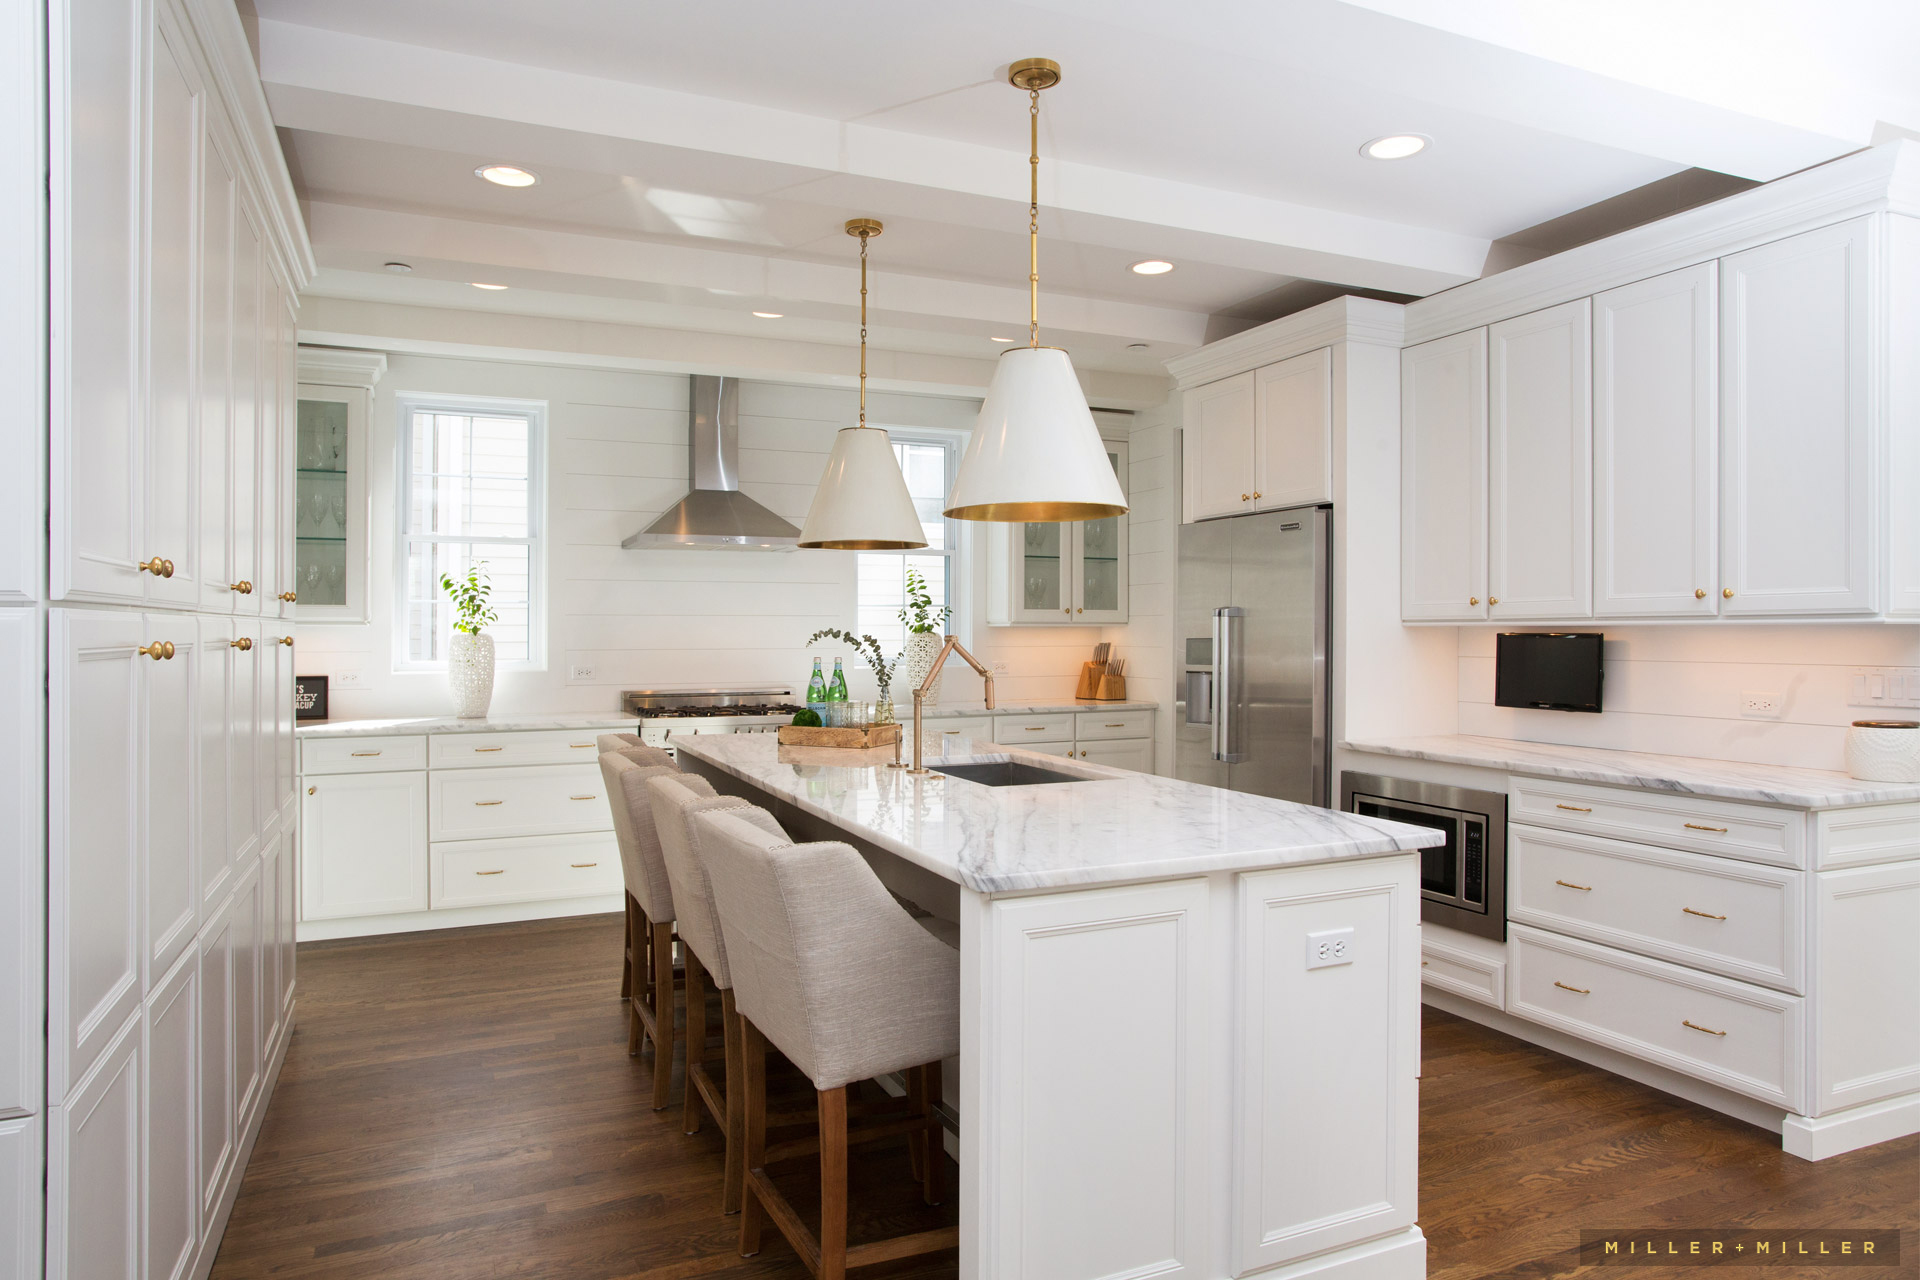If this kitchen could tell a story, what would it be? If this kitchen could tell a story, it would speak of countless shared moments and culinary adventures. It would recall the laughter of friends gathered around the island, the joyful chaos of holiday feasts, and the quiet mornings when the smell of freshly brewed coffee filled the air. This kitchen has witnessed the growth of a family, from the first steps of a child on its warm wooden floor to the hushed, late-night conversations. It would narrate the expertise honed over time, with each dish prepared on its resilient marble countertop and every appliance working seamlessly to create gastronomic delights. This kitchen embodies not just functionality, but also the heart of a home where every element works together to create a warm, inviting, and nurturing environment. How might this kitchen look in a futuristic, sci-fi inspired design? In a futuristic, sci-fi inspired design, this kitchen would undergo a stunning transformation. The countertops could be made of sleek, self-cleaning surfaces that change color according to the user’s mood or needs. Smart walls would display recipes, cooking videos, and personal messages, integrating seamlessly with AI assistants to perform tasks on command. Appliances might be voice-activated and could include multi-functional gadgets that cook, clean, and even dispense nutrition-enhanced meals. The cabinetry could have touch-sensitive panels that open with a light tap, while underfloor heating could adjust according to foot traffic, ensuring optimal comfort. Lighting would be adaptable, with fixtures capable of shifting from natural daylight to various ambient hues suitable for cooking, dining, or entertaining. The integration of holographic technology might allow chefs to visualize plating techniques step-by-step, making the kitchen a hub of culinary innovation and futuristic luxury. 